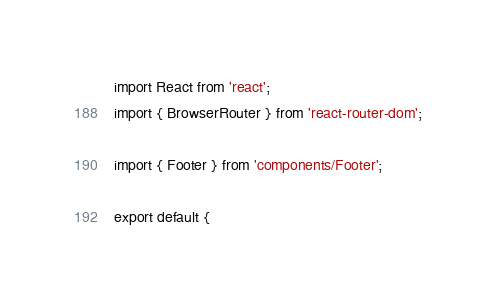<code> <loc_0><loc_0><loc_500><loc_500><_JavaScript_>import React from 'react';
import { BrowserRouter } from 'react-router-dom';

import { Footer } from 'components/Footer';

export default {</code> 